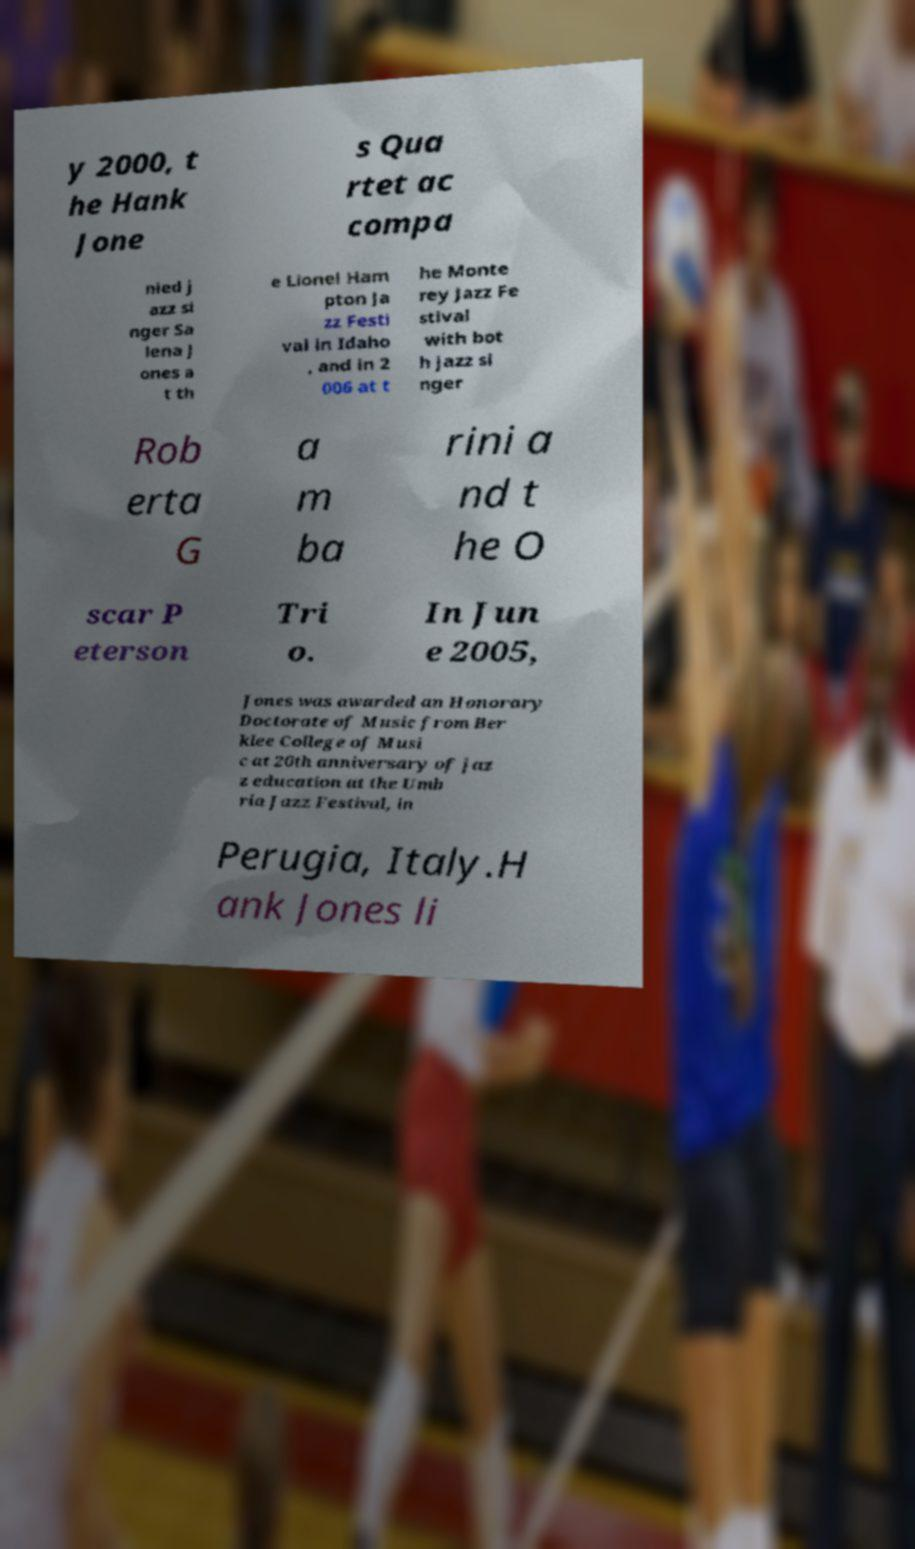Could you assist in decoding the text presented in this image and type it out clearly? y 2000, t he Hank Jone s Qua rtet ac compa nied j azz si nger Sa lena J ones a t th e Lionel Ham pton Ja zz Festi val in Idaho , and in 2 006 at t he Monte rey Jazz Fe stival with bot h jazz si nger Rob erta G a m ba rini a nd t he O scar P eterson Tri o. In Jun e 2005, Jones was awarded an Honorary Doctorate of Music from Ber klee College of Musi c at 20th anniversary of jaz z education at the Umb ria Jazz Festival, in Perugia, Italy.H ank Jones li 